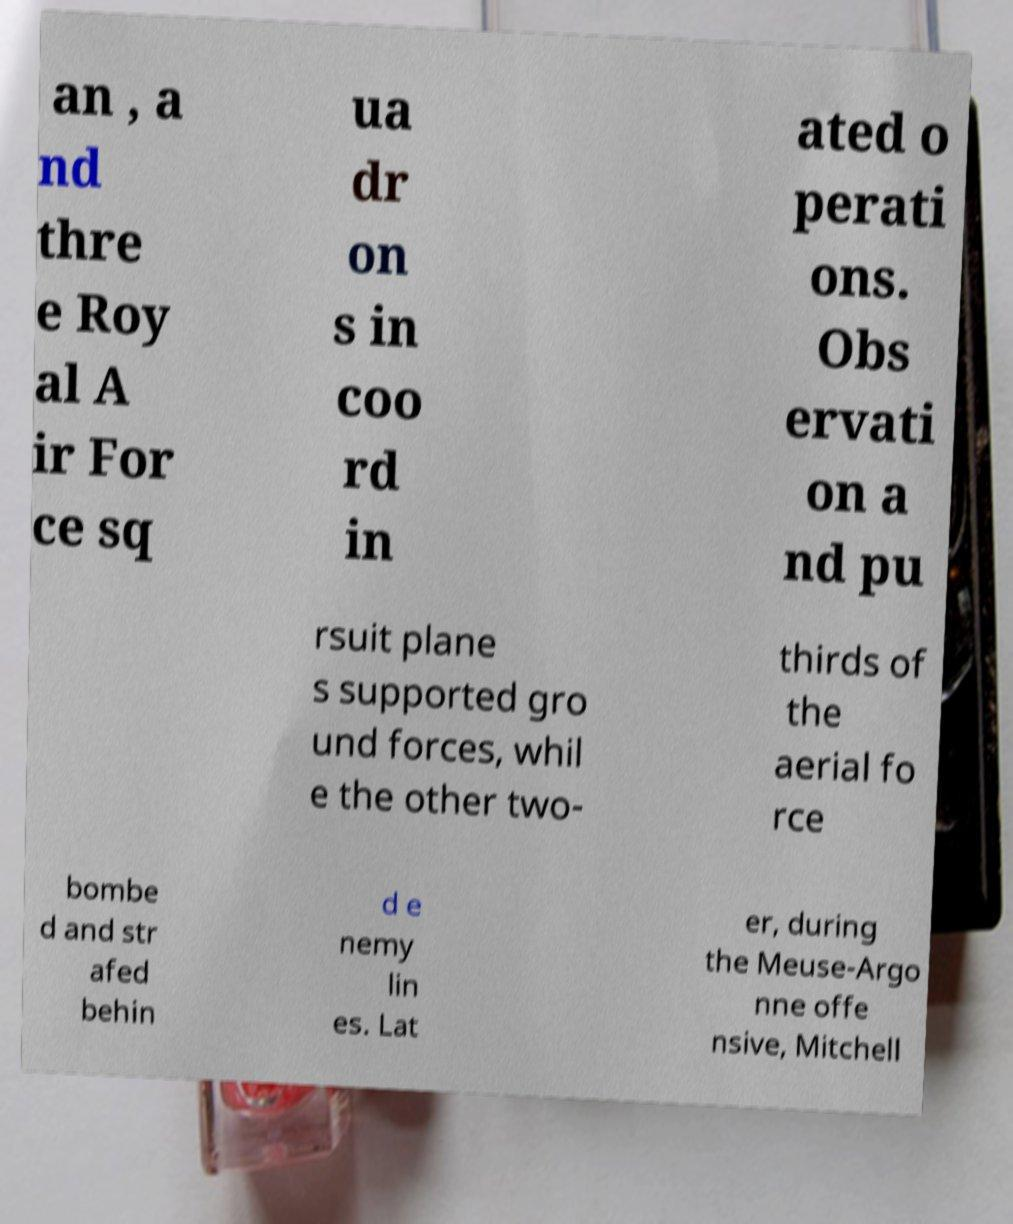Please identify and transcribe the text found in this image. an , a nd thre e Roy al A ir For ce sq ua dr on s in coo rd in ated o perati ons. Obs ervati on a nd pu rsuit plane s supported gro und forces, whil e the other two- thirds of the aerial fo rce bombe d and str afed behin d e nemy lin es. Lat er, during the Meuse-Argo nne offe nsive, Mitchell 